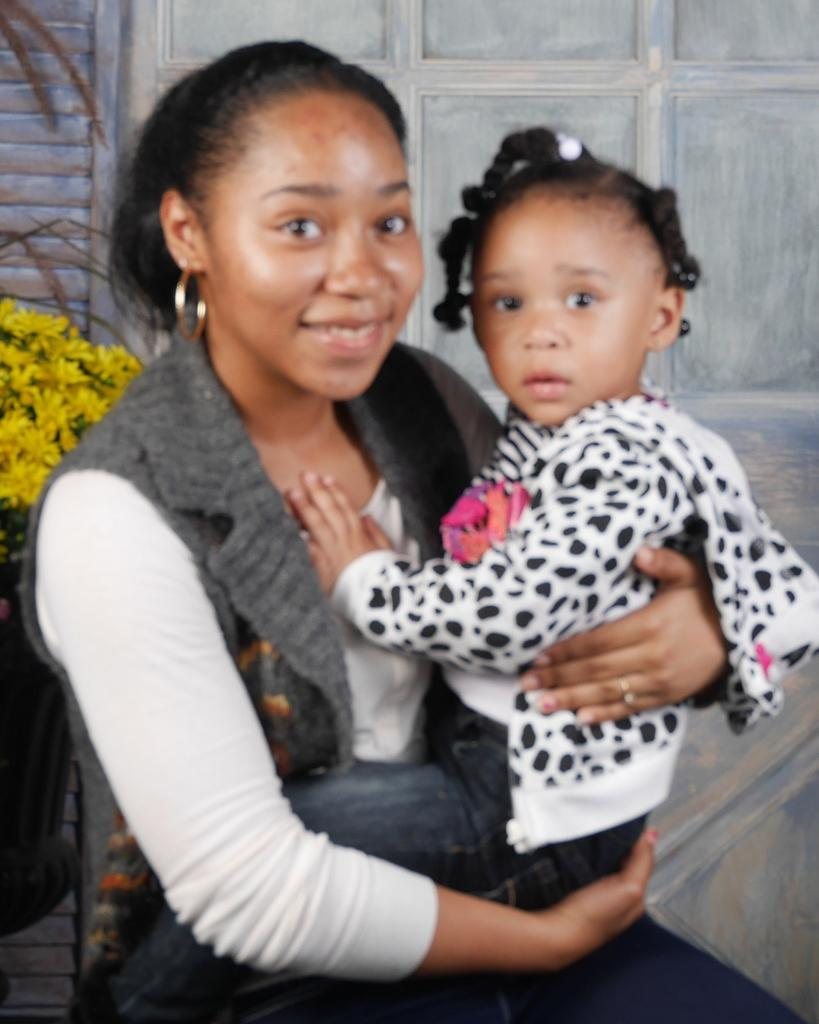What is the woman doing in the image? The woman is seated in a chair and holding a baby in her hand. What is the woman's facial expression in the image? The woman is smiling in the image. What can be seen behind the woman in the image? There are flowers and a wooden wall visible behind the woman. How does the zephyr affect the baby in the image? There is no mention of a zephyr or any wind in the image, so it cannot be determined how it would affect the baby. 